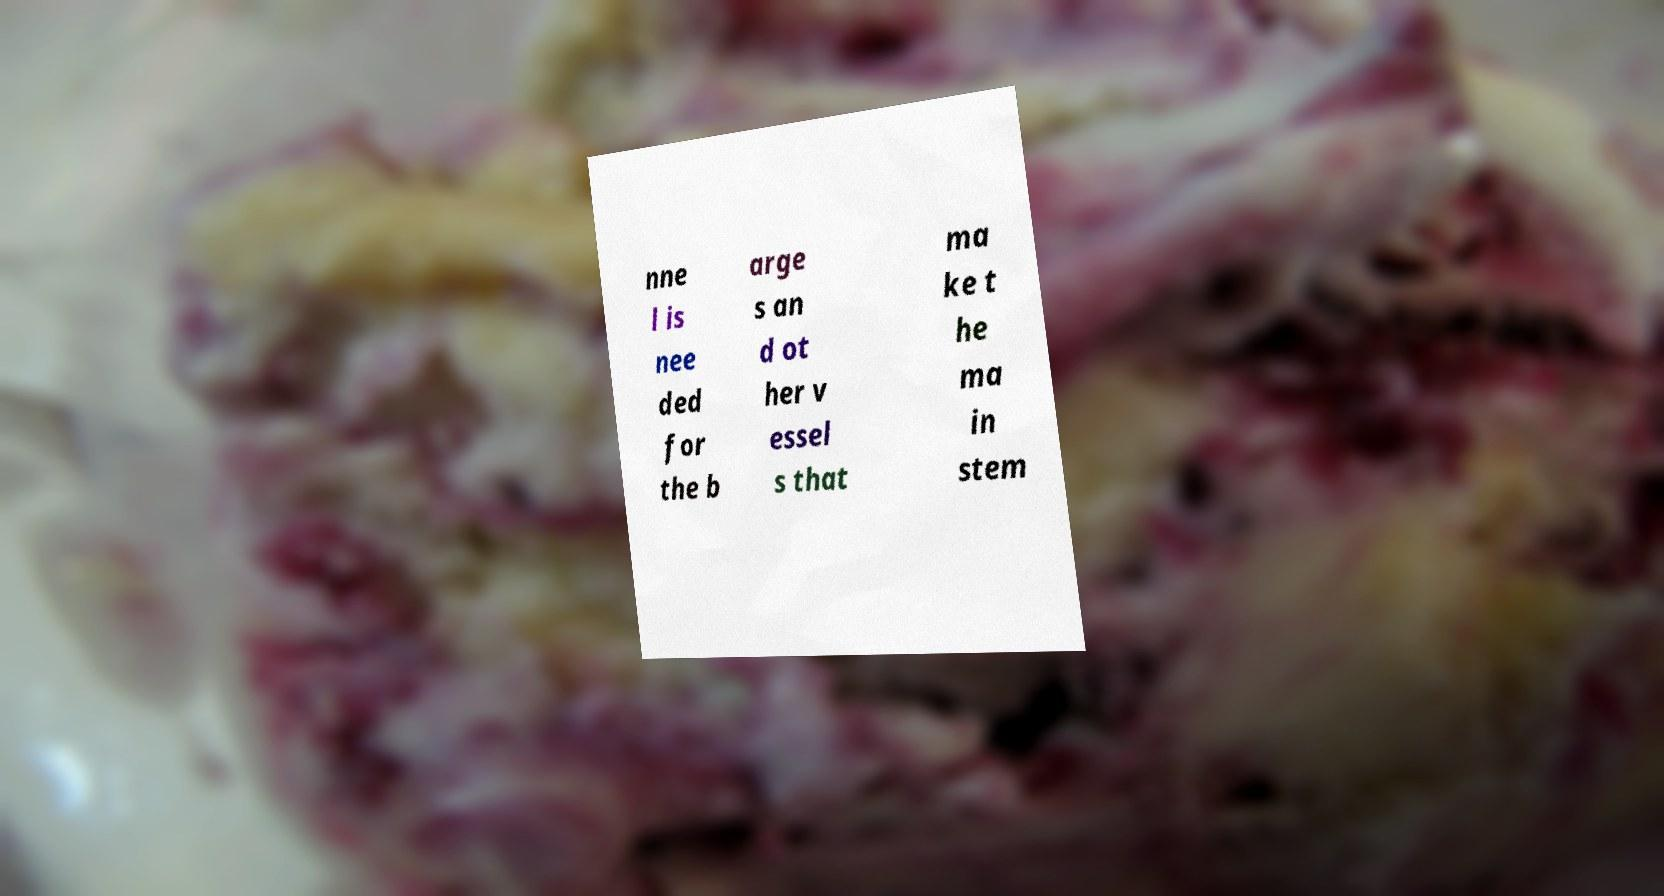Could you assist in decoding the text presented in this image and type it out clearly? nne l is nee ded for the b arge s an d ot her v essel s that ma ke t he ma in stem 